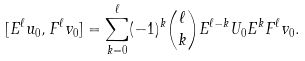<formula> <loc_0><loc_0><loc_500><loc_500>[ E ^ { \ell } u _ { 0 } , F ^ { \ell } v _ { 0 } ] = \sum _ { k = 0 } ^ { \ell } ( - 1 ) ^ { k } { \ell \choose k } E ^ { \ell - k } U _ { 0 } E ^ { k } F ^ { \ell } v _ { 0 } .</formula> 